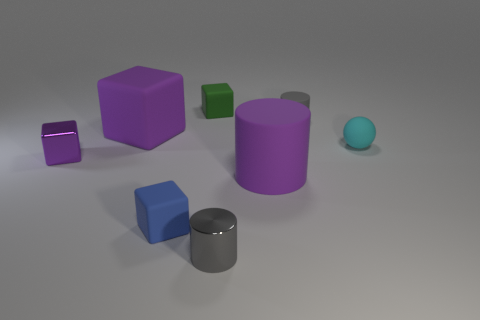Add 1 small purple cylinders. How many objects exist? 9 Subtract all rubber blocks. How many blocks are left? 1 Subtract all purple cylinders. How many cylinders are left? 2 Subtract 1 cubes. How many cubes are left? 3 Add 1 brown metallic objects. How many brown metallic objects exist? 1 Subtract 0 yellow cubes. How many objects are left? 8 Subtract all cylinders. How many objects are left? 5 Subtract all gray cubes. Subtract all yellow cylinders. How many cubes are left? 4 Subtract all yellow spheres. How many purple cylinders are left? 1 Subtract all gray metal cylinders. Subtract all green matte objects. How many objects are left? 6 